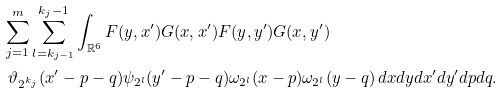<formula> <loc_0><loc_0><loc_500><loc_500>& \sum _ { j = 1 } ^ { m } \sum _ { l = k _ { j - 1 } } ^ { k _ { j } - 1 } \int _ { \mathbb { R } ^ { 6 } } F ( y , x ^ { \prime } ) G ( x , x ^ { \prime } ) F ( y , y ^ { \prime } ) G ( x , y ^ { \prime } ) \\ & \ \vartheta _ { 2 ^ { k _ { j } } } ( x ^ { \prime } - p - q ) \psi _ { 2 ^ { l } } ( y ^ { \prime } - p - q ) \omega _ { 2 ^ { l } } ( x - p ) \omega _ { 2 ^ { l } } ( y - q ) \, d x d y d x ^ { \prime } d y ^ { \prime } d p d q .</formula> 